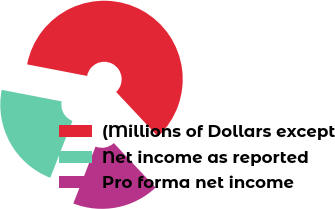Convert chart to OTSL. <chart><loc_0><loc_0><loc_500><loc_500><pie_chart><fcel>(Millions of Dollars except<fcel>Net income as reported<fcel>Pro forma net income<nl><fcel>59.98%<fcel>22.11%<fcel>17.91%<nl></chart> 